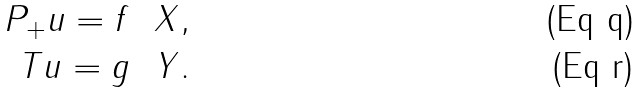Convert formula to latex. <formula><loc_0><loc_0><loc_500><loc_500>P _ { + } u = f \ \ X , \\ T u = g \ \ Y .</formula> 